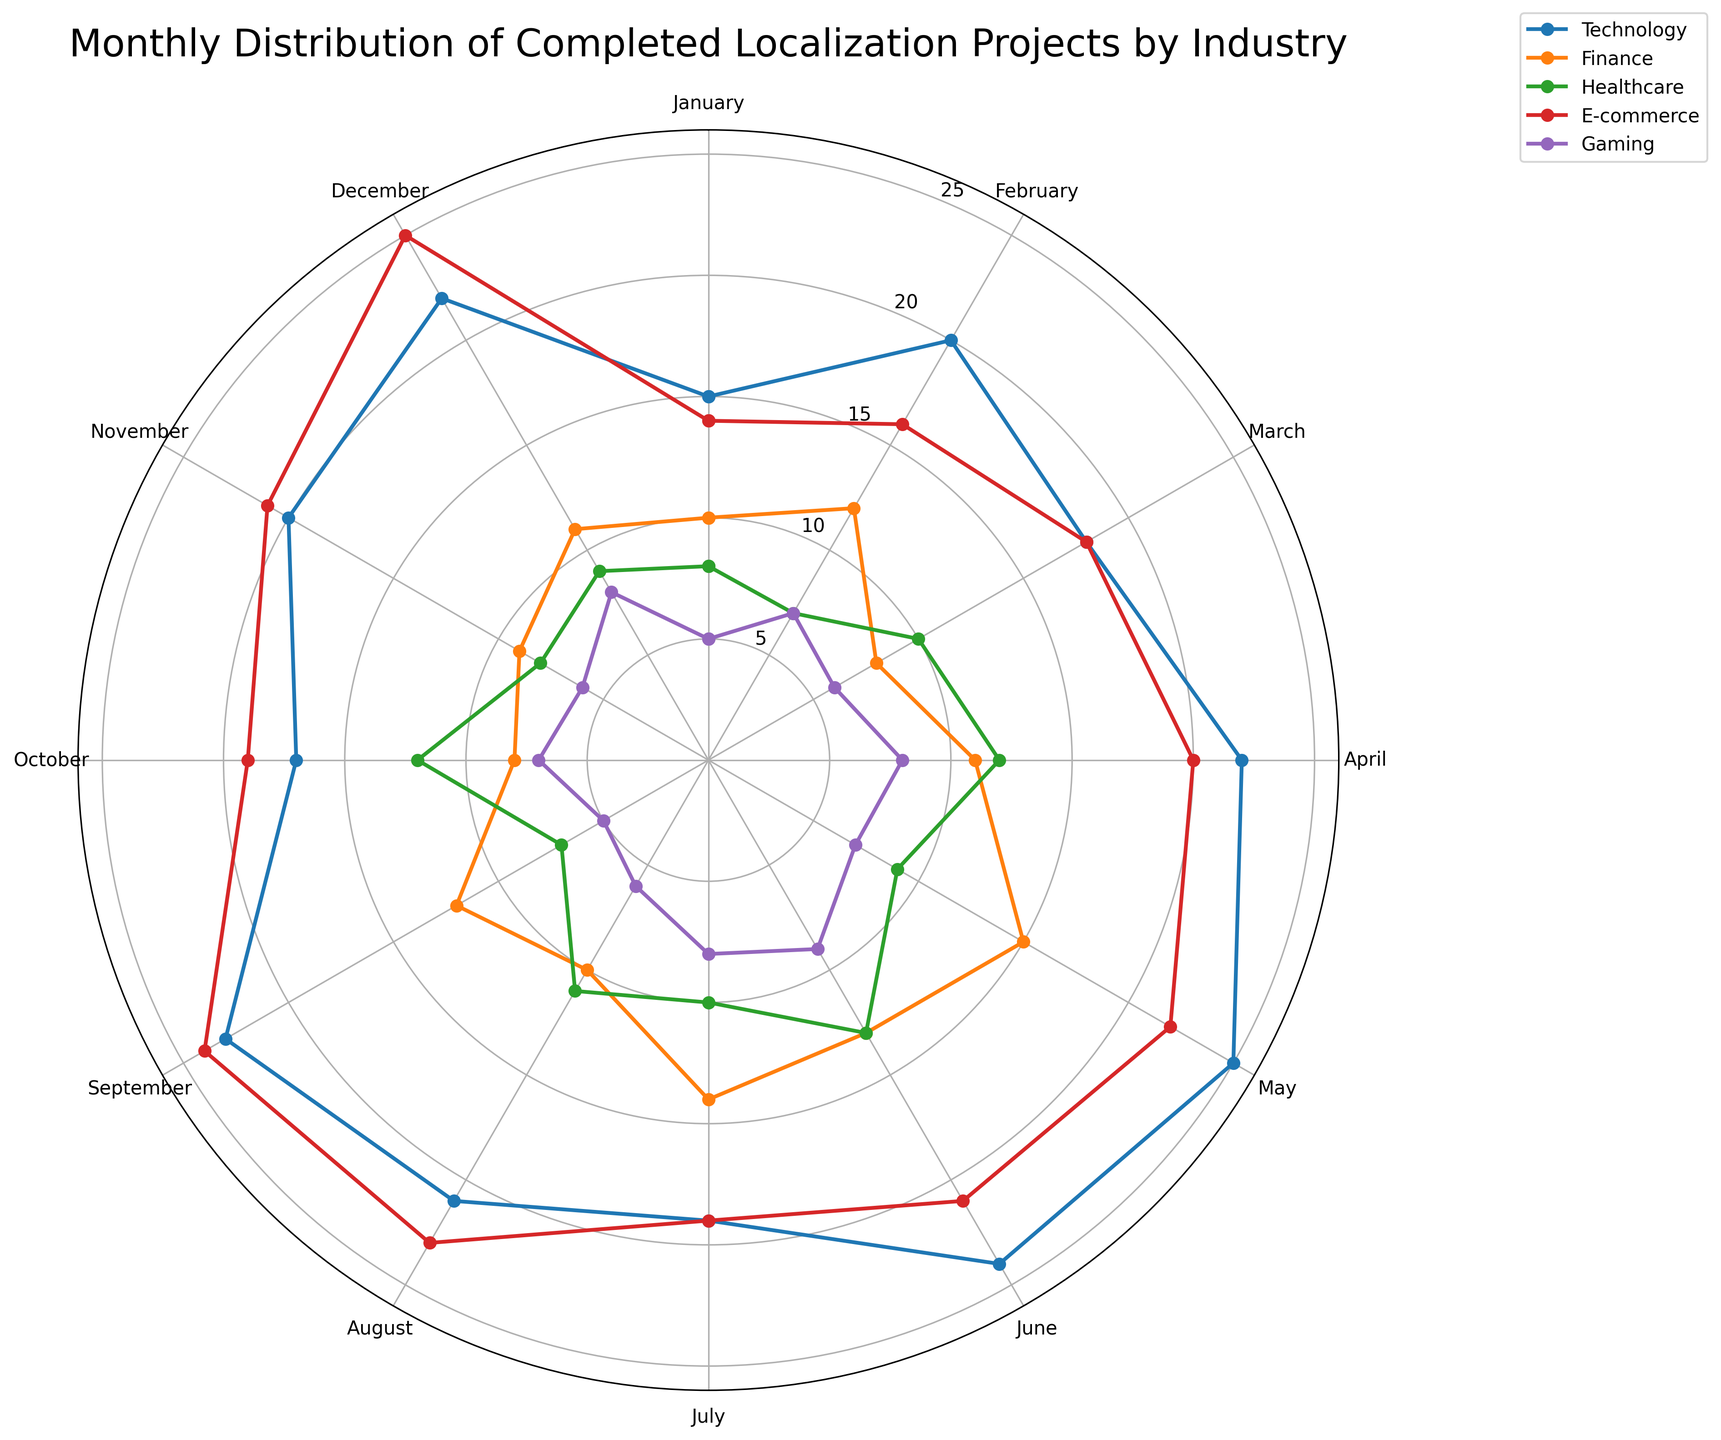Which industry has the highest number of completed projects in May? To determine the industry with the highest number of completed projects in May, we look at the corresponding points in the figure for each industry. E-commerce shows the highest spike in May.
Answer: E-commerce Compare the number of completed projects in January between Technology and Finance industries. Which has more? By observing the figure, the Technology sector's plot is higher than that of the Finance sector in January. Hence, Technology has more completed projects.
Answer: Technology What is the total number of completed projects for Healthcare in Q1 (January to March)? Add the completed projects for Healthcare in January (8), February (7), and March (10). Total = 8 + 7 + 10 = 25
Answer: 25 Between March and August, which month has the fewest completed projects for Gaming? By inspecting the Gaming sector's curve from March to August, the lowest point appears in March, with 6 completed projects.
Answer: March Is the number of completed projects for Finance in April greater than or less than in October? In the figure, the plot for April is higher than for October for the Finance sector, indicating that April has more completed projects.
Answer: Greater than Which industry shows the most consistent number of completed projects throughout the year? The most consistent trend would be the one whose plot has minimal peaks and valleys. The Gaming sector illustrates the most consistency.
Answer: Gaming What is the average number of completed projects for Technology from June to September? Add the numbers of completed projects from June to September for Technology: 24 + 19 + 21 + 23, and divide by 4: Average = (24 + 19 + 21 + 23) / 4 = 21.75
Answer: 21.75 In which month does E-commerce achieve its peak number of completed projects? The E-commerce sector reaches its highest point in December.
Answer: December How does the number of completed projects in December for Gaming compare to Healthcare? Comparing the data points for Gaming and Healthcare in December, both sectors have 8 and 9 completed projects, respectively. Hence, Healthcare has more.
Answer: Healthcare 